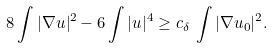<formula> <loc_0><loc_0><loc_500><loc_500>8 \int | \nabla u | ^ { 2 } - 6 \int | u | ^ { 4 } \geq c _ { \delta } \, \int | \nabla u _ { 0 } | ^ { 2 } .</formula> 